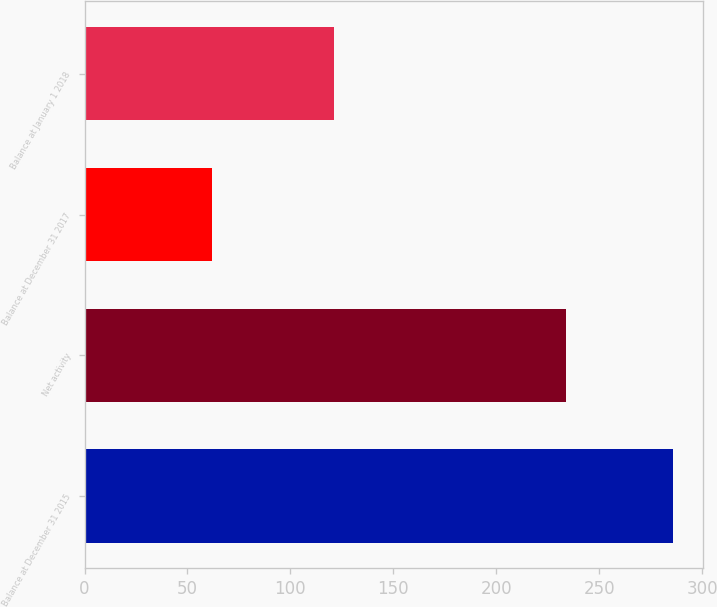Convert chart. <chart><loc_0><loc_0><loc_500><loc_500><bar_chart><fcel>Balance at December 31 2015<fcel>Net activity<fcel>Balance at December 31 2017<fcel>Balance at January 1 2018<nl><fcel>286<fcel>234<fcel>62<fcel>121<nl></chart> 